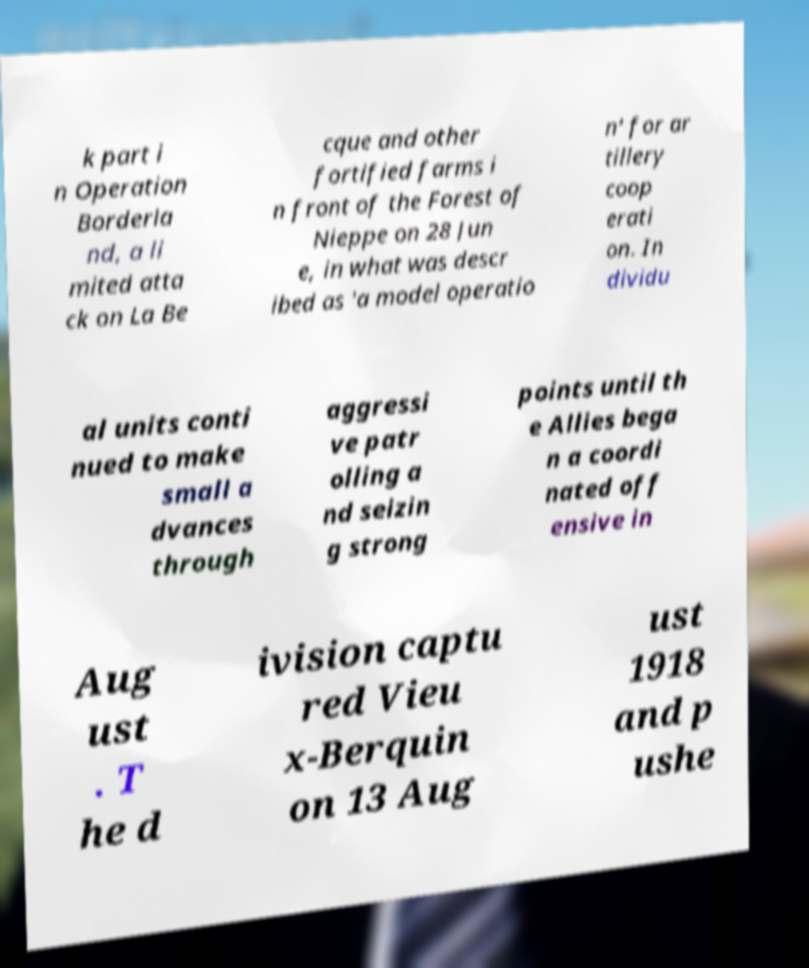Can you accurately transcribe the text from the provided image for me? k part i n Operation Borderla nd, a li mited atta ck on La Be cque and other fortified farms i n front of the Forest of Nieppe on 28 Jun e, in what was descr ibed as 'a model operatio n' for ar tillery coop erati on. In dividu al units conti nued to make small a dvances through aggressi ve patr olling a nd seizin g strong points until th e Allies bega n a coordi nated off ensive in Aug ust . T he d ivision captu red Vieu x-Berquin on 13 Aug ust 1918 and p ushe 